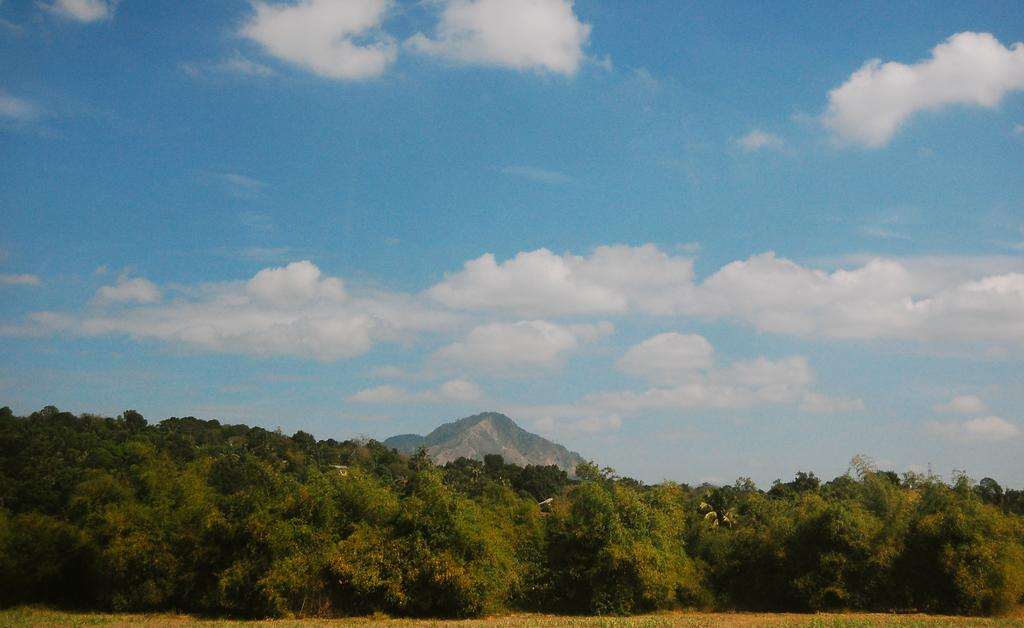What type of vegetation is at the bottom of the image? There are trees at the bottom of the image. What is located behind the trees? There is a hill behind the trees. What is visible at the top of the image? The sky is visible at the top of the image. What can be seen in the sky? Clouds are present in the sky. How many screws can be seen holding the sky in place in the image? There are no screws present in the image, and the sky is not held in place by any visible means. Are there any slaves depicted in the image? There is no reference to any slaves or slavery in the image. 